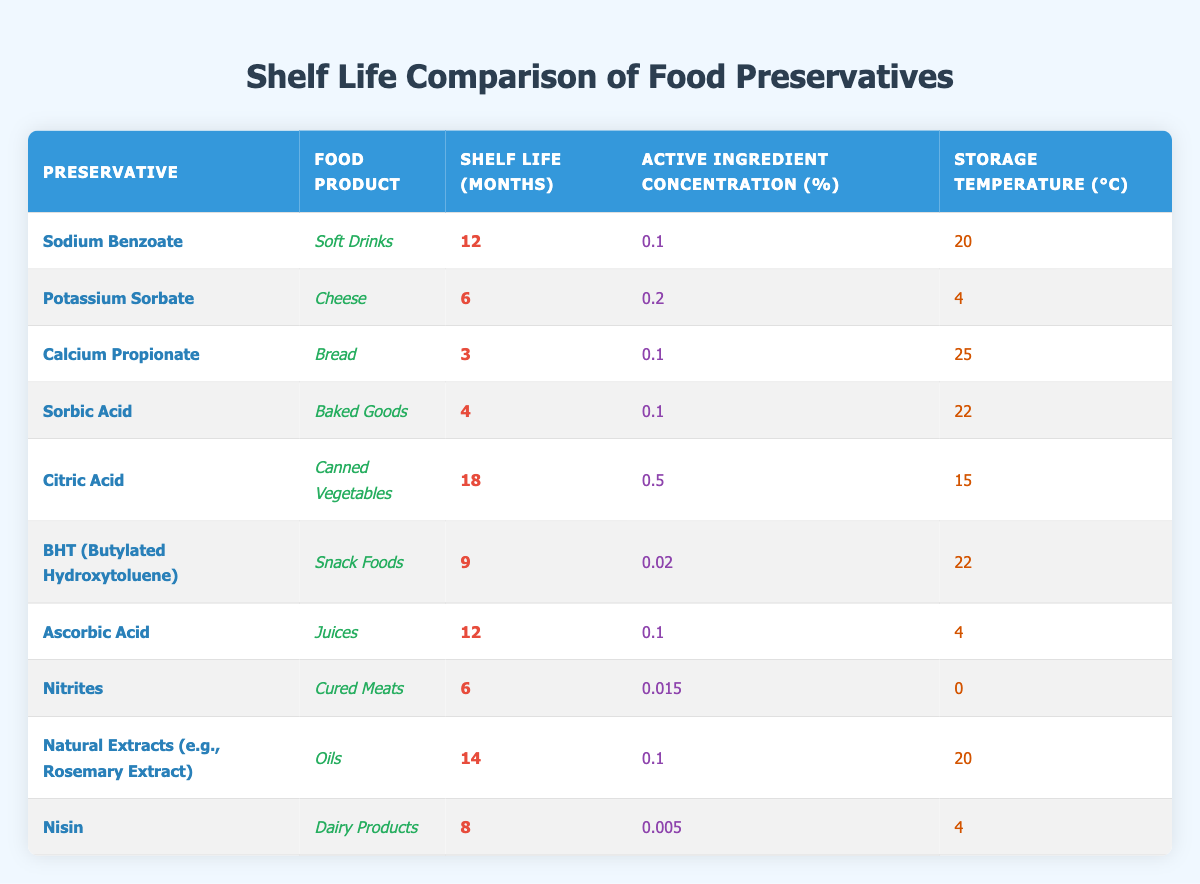What is the shelf life of Sodium Benzoate when used in soft drinks? According to the table, Sodium Benzoate has a shelf life of 12 months when used in soft drinks.
Answer: 12 months Which preservative has the highest shelf life, and what food product does it preserve? The highest shelf life is 18 months, which belongs to Citric Acid used in canned vegetables.
Answer: Citric Acid, Canned Vegetables Is the active ingredient concentration higher in Potassium Sorbate or Nisin? Potassium Sorbate has an active ingredient concentration of 0.2%, while Nisin has 0.005%. Therefore, Potassium Sorbate has a higher concentration.
Answer: Yes What is the average shelf life of the food products listed? To calculate the average, we add all the shelf life values: (12 + 6 + 3 + 4 + 18 + 9 + 12 + 6 + 14 + 8) = 92. There are 10 products, so the average shelf life is 92/10 = 9.2 months.
Answer: 9.2 months Which food product has the shortest shelf life, and what is that shelf life? The food product with the shortest shelf life is Bread, with a shelf life of 3 months when using Calcium Propionate as a preservative.
Answer: Bread, 3 months Are both Ascorbic Acid and Sodium Benzoate used in products with the same shelf life? Yes, both Ascorbic Acid and Sodium Benzoate have a shelf life of 12 months for their respective products (Juices and Soft Drinks).
Answer: Yes Calculate the difference in shelf life between Citric Acid and Sorbic Acid. Citric Acid has a shelf life of 18 months, and Sorbic Acid has 4 months. The difference is 18 - 4 = 14 months.
Answer: 14 months For which food product does Natural Extracts have a longer shelf life compared to its active ingredient concentration? Natural Extracts has a shelf life of 14 months and an active ingredient concentration of 0.1%. This concentration is relatively low compared to the shelf life achieved.
Answer: Oils What is the effect of increasing the storage temperature on the shelf life of Calcium Propionate used in bread? The table indicates that Calcium Propionate has a storage temperature of 25°C and a shelf life of 3 months. There are no other samples at different temperatures for direct comparison, so we can't draw a firm conclusion about the effects of temperature on shelf life specifically for this preservative.
Answer: Cannot determine 